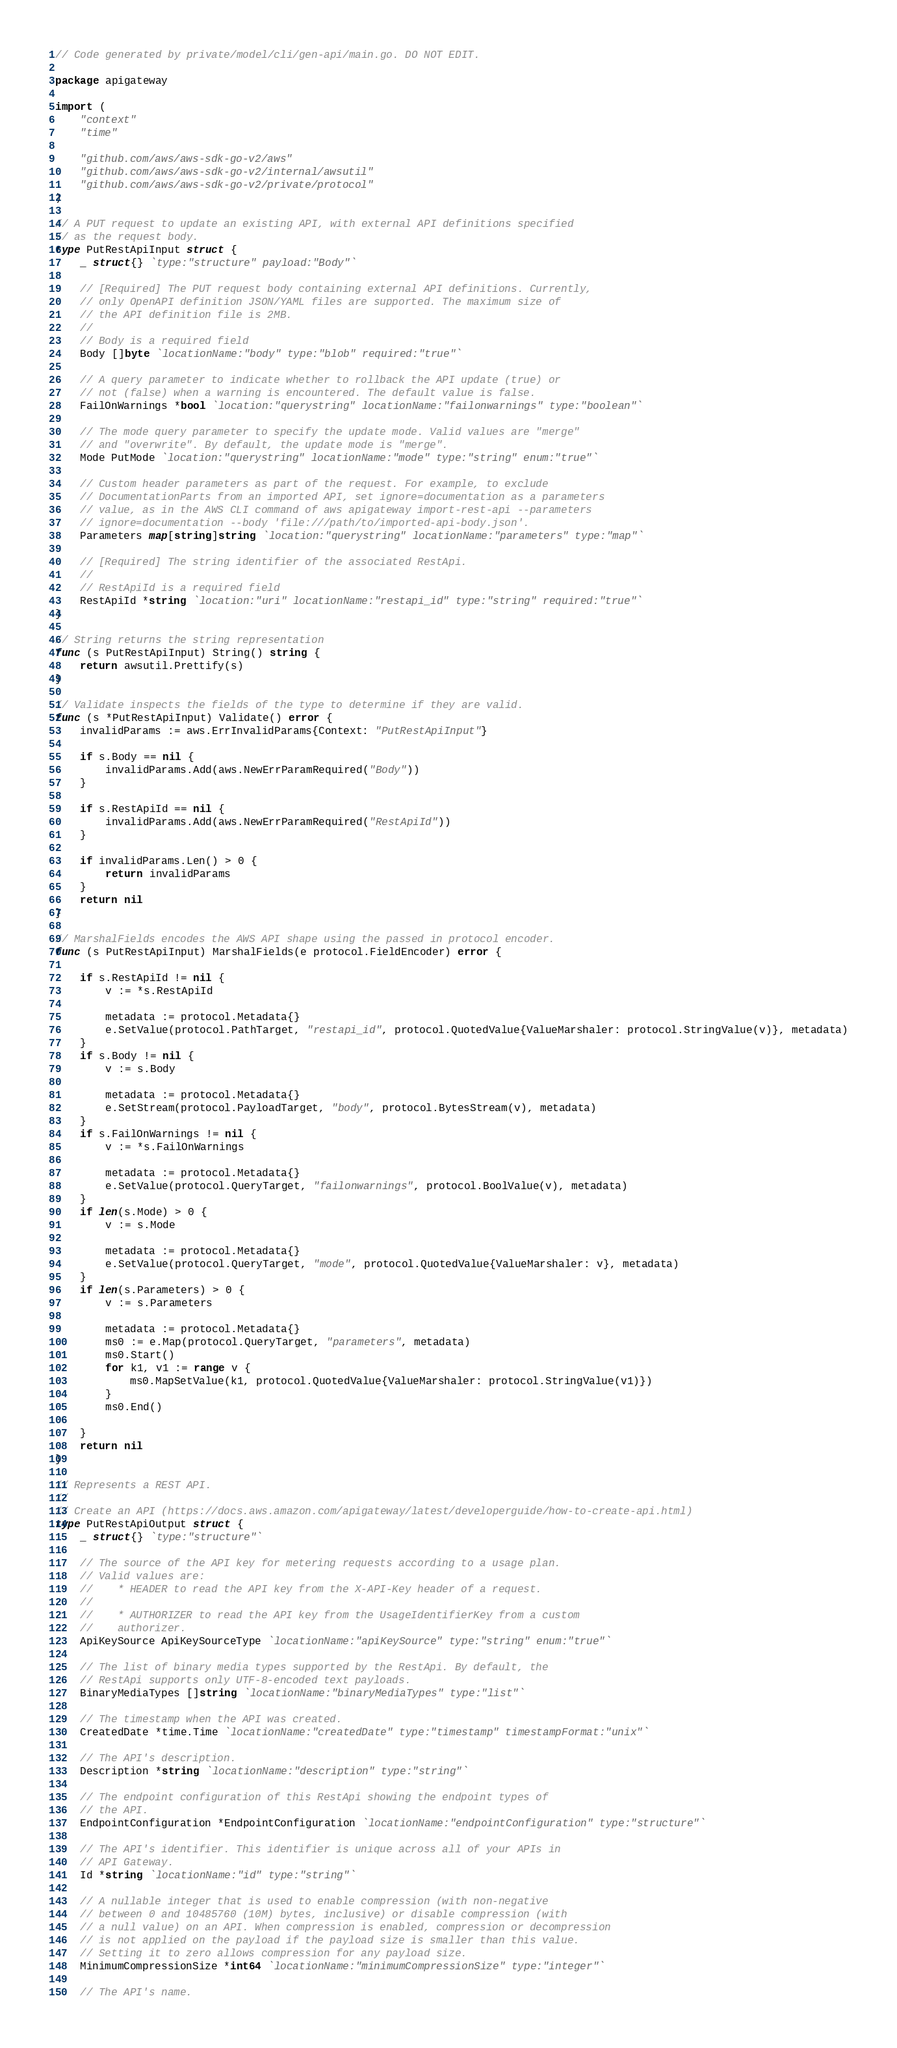<code> <loc_0><loc_0><loc_500><loc_500><_Go_>// Code generated by private/model/cli/gen-api/main.go. DO NOT EDIT.

package apigateway

import (
	"context"
	"time"

	"github.com/aws/aws-sdk-go-v2/aws"
	"github.com/aws/aws-sdk-go-v2/internal/awsutil"
	"github.com/aws/aws-sdk-go-v2/private/protocol"
)

// A PUT request to update an existing API, with external API definitions specified
// as the request body.
type PutRestApiInput struct {
	_ struct{} `type:"structure" payload:"Body"`

	// [Required] The PUT request body containing external API definitions. Currently,
	// only OpenAPI definition JSON/YAML files are supported. The maximum size of
	// the API definition file is 2MB.
	//
	// Body is a required field
	Body []byte `locationName:"body" type:"blob" required:"true"`

	// A query parameter to indicate whether to rollback the API update (true) or
	// not (false) when a warning is encountered. The default value is false.
	FailOnWarnings *bool `location:"querystring" locationName:"failonwarnings" type:"boolean"`

	// The mode query parameter to specify the update mode. Valid values are "merge"
	// and "overwrite". By default, the update mode is "merge".
	Mode PutMode `location:"querystring" locationName:"mode" type:"string" enum:"true"`

	// Custom header parameters as part of the request. For example, to exclude
	// DocumentationParts from an imported API, set ignore=documentation as a parameters
	// value, as in the AWS CLI command of aws apigateway import-rest-api --parameters
	// ignore=documentation --body 'file:///path/to/imported-api-body.json'.
	Parameters map[string]string `location:"querystring" locationName:"parameters" type:"map"`

	// [Required] The string identifier of the associated RestApi.
	//
	// RestApiId is a required field
	RestApiId *string `location:"uri" locationName:"restapi_id" type:"string" required:"true"`
}

// String returns the string representation
func (s PutRestApiInput) String() string {
	return awsutil.Prettify(s)
}

// Validate inspects the fields of the type to determine if they are valid.
func (s *PutRestApiInput) Validate() error {
	invalidParams := aws.ErrInvalidParams{Context: "PutRestApiInput"}

	if s.Body == nil {
		invalidParams.Add(aws.NewErrParamRequired("Body"))
	}

	if s.RestApiId == nil {
		invalidParams.Add(aws.NewErrParamRequired("RestApiId"))
	}

	if invalidParams.Len() > 0 {
		return invalidParams
	}
	return nil
}

// MarshalFields encodes the AWS API shape using the passed in protocol encoder.
func (s PutRestApiInput) MarshalFields(e protocol.FieldEncoder) error {

	if s.RestApiId != nil {
		v := *s.RestApiId

		metadata := protocol.Metadata{}
		e.SetValue(protocol.PathTarget, "restapi_id", protocol.QuotedValue{ValueMarshaler: protocol.StringValue(v)}, metadata)
	}
	if s.Body != nil {
		v := s.Body

		metadata := protocol.Metadata{}
		e.SetStream(protocol.PayloadTarget, "body", protocol.BytesStream(v), metadata)
	}
	if s.FailOnWarnings != nil {
		v := *s.FailOnWarnings

		metadata := protocol.Metadata{}
		e.SetValue(protocol.QueryTarget, "failonwarnings", protocol.BoolValue(v), metadata)
	}
	if len(s.Mode) > 0 {
		v := s.Mode

		metadata := protocol.Metadata{}
		e.SetValue(protocol.QueryTarget, "mode", protocol.QuotedValue{ValueMarshaler: v}, metadata)
	}
	if len(s.Parameters) > 0 {
		v := s.Parameters

		metadata := protocol.Metadata{}
		ms0 := e.Map(protocol.QueryTarget, "parameters", metadata)
		ms0.Start()
		for k1, v1 := range v {
			ms0.MapSetValue(k1, protocol.QuotedValue{ValueMarshaler: protocol.StringValue(v1)})
		}
		ms0.End()

	}
	return nil
}

// Represents a REST API.
//
// Create an API (https://docs.aws.amazon.com/apigateway/latest/developerguide/how-to-create-api.html)
type PutRestApiOutput struct {
	_ struct{} `type:"structure"`

	// The source of the API key for metering requests according to a usage plan.
	// Valid values are:
	//    * HEADER to read the API key from the X-API-Key header of a request.
	//
	//    * AUTHORIZER to read the API key from the UsageIdentifierKey from a custom
	//    authorizer.
	ApiKeySource ApiKeySourceType `locationName:"apiKeySource" type:"string" enum:"true"`

	// The list of binary media types supported by the RestApi. By default, the
	// RestApi supports only UTF-8-encoded text payloads.
	BinaryMediaTypes []string `locationName:"binaryMediaTypes" type:"list"`

	// The timestamp when the API was created.
	CreatedDate *time.Time `locationName:"createdDate" type:"timestamp" timestampFormat:"unix"`

	// The API's description.
	Description *string `locationName:"description" type:"string"`

	// The endpoint configuration of this RestApi showing the endpoint types of
	// the API.
	EndpointConfiguration *EndpointConfiguration `locationName:"endpointConfiguration" type:"structure"`

	// The API's identifier. This identifier is unique across all of your APIs in
	// API Gateway.
	Id *string `locationName:"id" type:"string"`

	// A nullable integer that is used to enable compression (with non-negative
	// between 0 and 10485760 (10M) bytes, inclusive) or disable compression (with
	// a null value) on an API. When compression is enabled, compression or decompression
	// is not applied on the payload if the payload size is smaller than this value.
	// Setting it to zero allows compression for any payload size.
	MinimumCompressionSize *int64 `locationName:"minimumCompressionSize" type:"integer"`

	// The API's name.</code> 